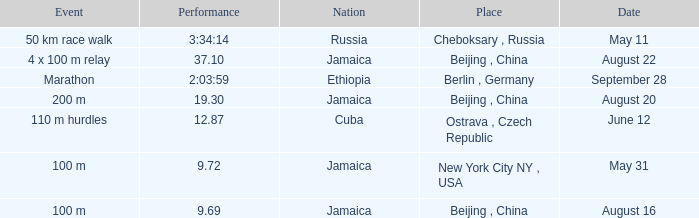Which nation ran a time of 9.69 seconds? Jamaica. 